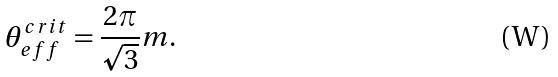Convert formula to latex. <formula><loc_0><loc_0><loc_500><loc_500>\theta _ { e f f } ^ { c r i t } = \frac { 2 \pi } { \sqrt { 3 } } m .</formula> 